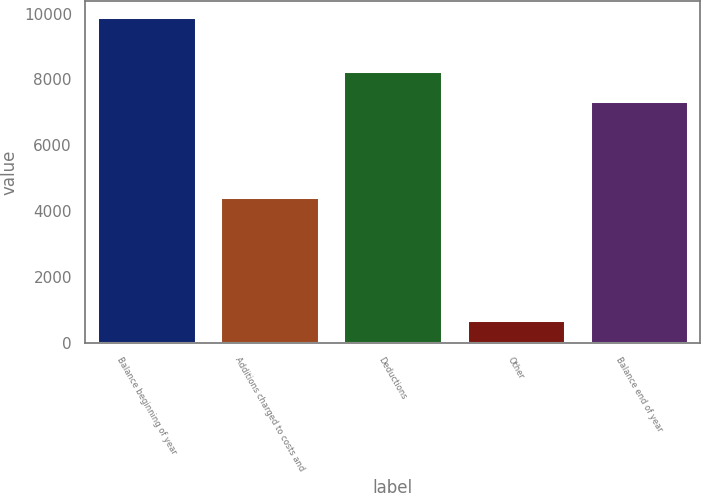<chart> <loc_0><loc_0><loc_500><loc_500><bar_chart><fcel>Balance beginning of year<fcel>Additions charged to costs and<fcel>Deductions<fcel>Other<fcel>Balance end of year<nl><fcel>9885<fcel>4416<fcel>8259.6<fcel>699<fcel>7341<nl></chart> 